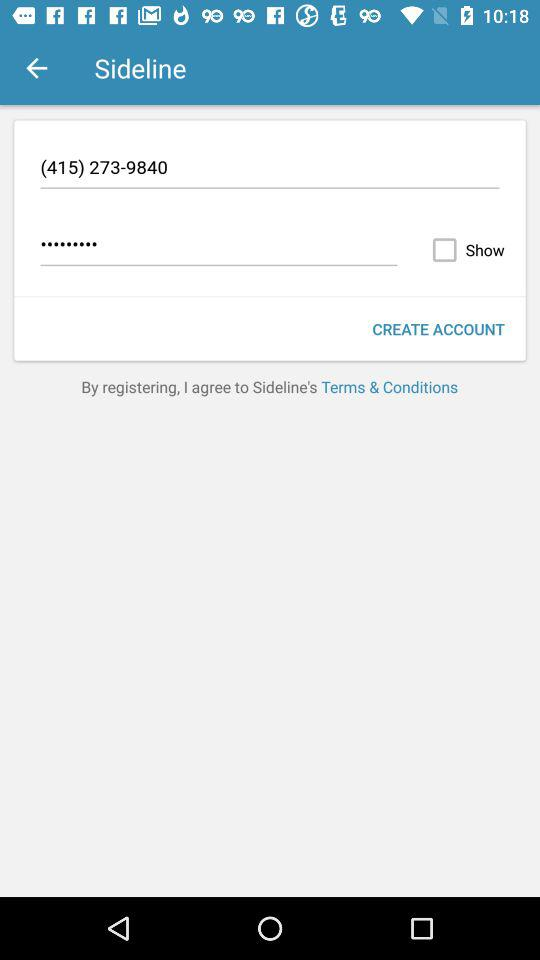What is the phone number? The phone number is (415) 273-9840. 